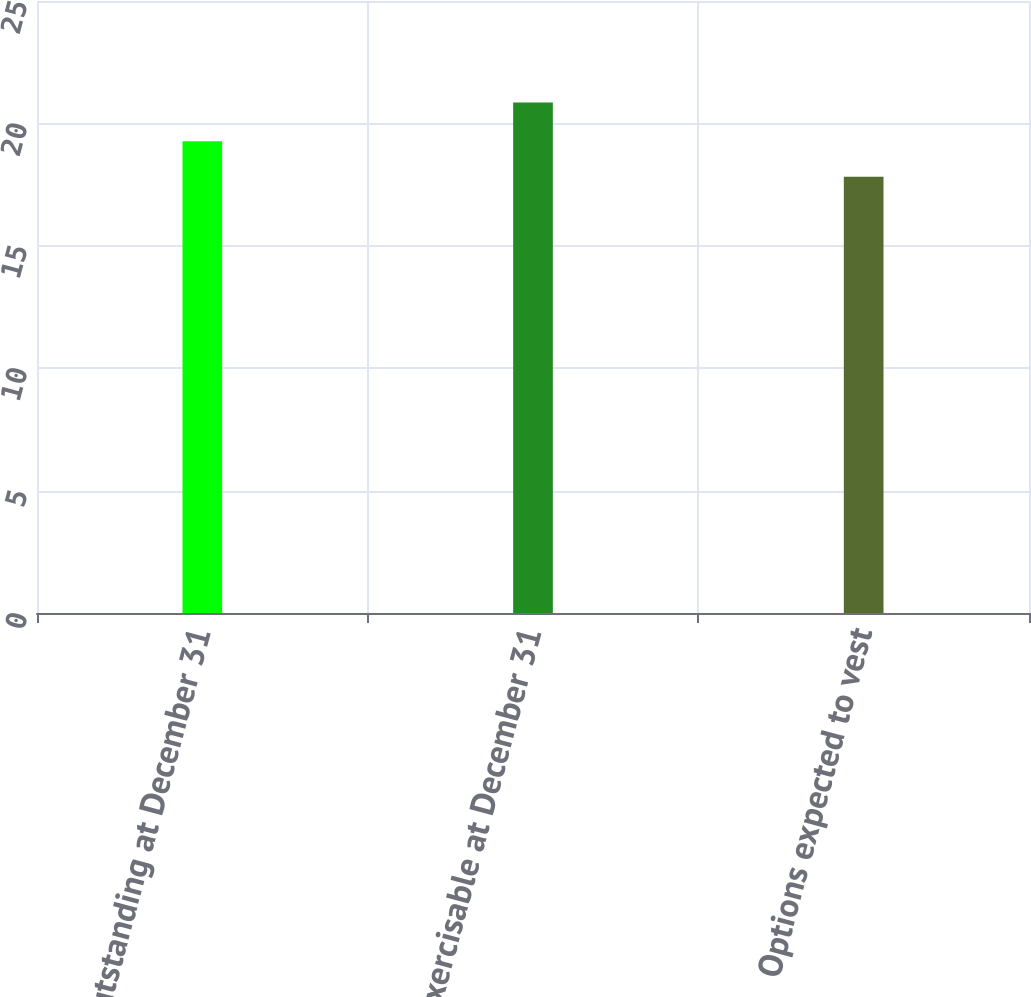Convert chart. <chart><loc_0><loc_0><loc_500><loc_500><bar_chart><fcel>Outstanding at December 31<fcel>Exercisable at December 31<fcel>Options expected to vest<nl><fcel>19.27<fcel>20.85<fcel>17.82<nl></chart> 